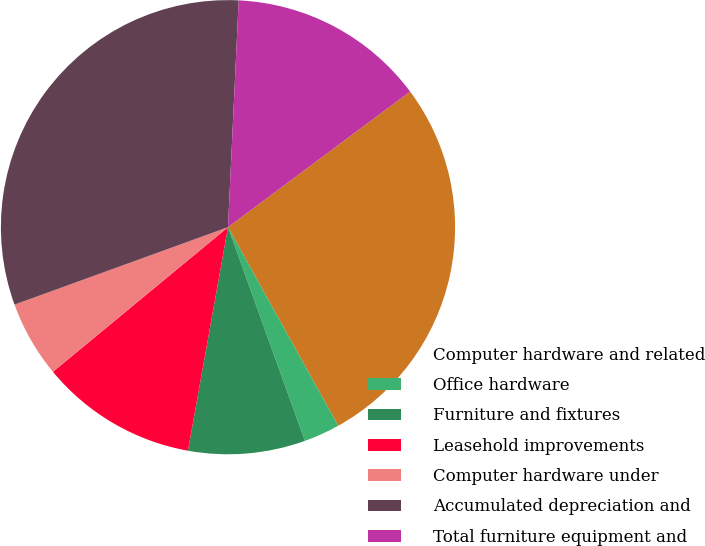Convert chart to OTSL. <chart><loc_0><loc_0><loc_500><loc_500><pie_chart><fcel>Computer hardware and related<fcel>Office hardware<fcel>Furniture and fixtures<fcel>Leasehold improvements<fcel>Computer hardware under<fcel>Accumulated depreciation and<fcel>Total furniture equipment and<nl><fcel>27.12%<fcel>2.57%<fcel>8.32%<fcel>11.19%<fcel>5.45%<fcel>31.29%<fcel>14.06%<nl></chart> 